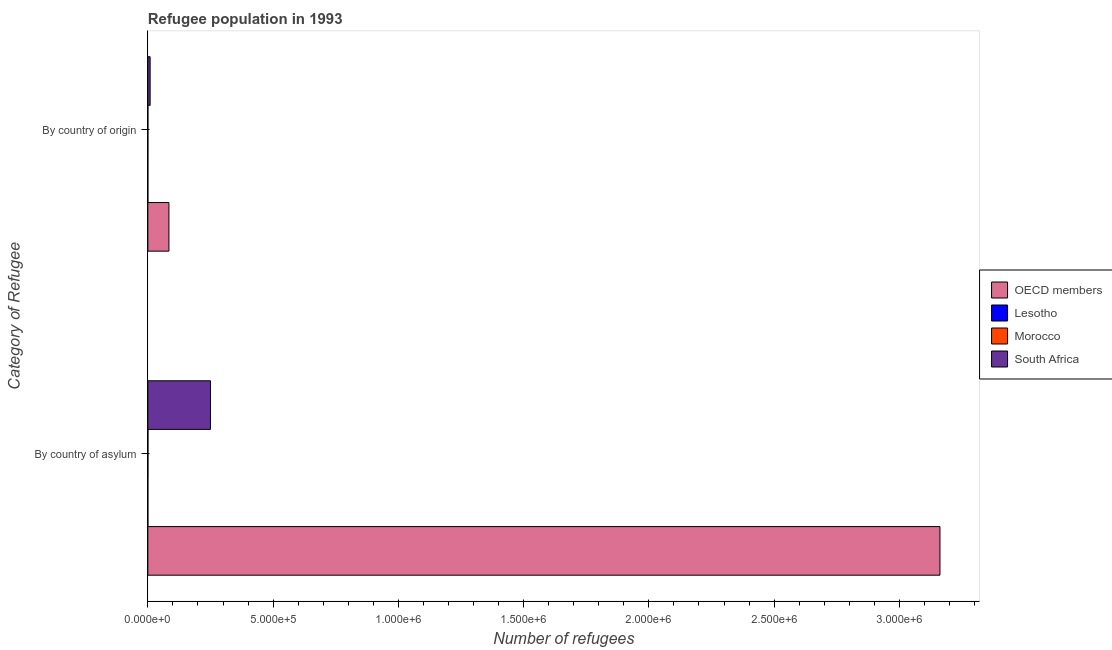How many different coloured bars are there?
Your answer should be compact. 4. Are the number of bars on each tick of the Y-axis equal?
Give a very brief answer. Yes. How many bars are there on the 1st tick from the bottom?
Give a very brief answer. 4. What is the label of the 2nd group of bars from the top?
Your answer should be very brief. By country of asylum. What is the number of refugees by country of asylum in OECD members?
Provide a succinct answer. 3.16e+06. Across all countries, what is the maximum number of refugees by country of origin?
Ensure brevity in your answer.  8.41e+04. Across all countries, what is the minimum number of refugees by country of origin?
Ensure brevity in your answer.  55. In which country was the number of refugees by country of asylum minimum?
Ensure brevity in your answer.  Lesotho. What is the total number of refugees by country of asylum in the graph?
Provide a short and direct response. 3.41e+06. What is the difference between the number of refugees by country of origin in Lesotho and that in OECD members?
Make the answer very short. -8.41e+04. What is the difference between the number of refugees by country of origin in Morocco and the number of refugees by country of asylum in Lesotho?
Make the answer very short. 45. What is the average number of refugees by country of asylum per country?
Offer a terse response. 8.53e+05. What is the difference between the number of refugees by country of origin and number of refugees by country of asylum in Lesotho?
Make the answer very short. -5. In how many countries, is the number of refugees by country of asylum greater than 1100000 ?
Provide a short and direct response. 1. What is the ratio of the number of refugees by country of asylum in Morocco to that in Lesotho?
Your answer should be very brief. 5.6. Is the number of refugees by country of asylum in Lesotho less than that in Morocco?
Ensure brevity in your answer.  Yes. What does the 2nd bar from the bottom in By country of asylum represents?
Your answer should be compact. Lesotho. How many countries are there in the graph?
Your answer should be compact. 4. Are the values on the major ticks of X-axis written in scientific E-notation?
Offer a very short reply. Yes. Does the graph contain grids?
Provide a short and direct response. No. How many legend labels are there?
Provide a short and direct response. 4. What is the title of the graph?
Your answer should be very brief. Refugee population in 1993. Does "Northern Mariana Islands" appear as one of the legend labels in the graph?
Make the answer very short. No. What is the label or title of the X-axis?
Keep it short and to the point. Number of refugees. What is the label or title of the Y-axis?
Provide a succinct answer. Category of Refugee. What is the Number of refugees of OECD members in By country of asylum?
Provide a short and direct response. 3.16e+06. What is the Number of refugees in Lesotho in By country of asylum?
Ensure brevity in your answer.  60. What is the Number of refugees in Morocco in By country of asylum?
Make the answer very short. 336. What is the Number of refugees in South Africa in By country of asylum?
Give a very brief answer. 2.50e+05. What is the Number of refugees in OECD members in By country of origin?
Your answer should be very brief. 8.41e+04. What is the Number of refugees of Lesotho in By country of origin?
Your answer should be compact. 55. What is the Number of refugees of Morocco in By country of origin?
Offer a terse response. 105. What is the Number of refugees of South Africa in By country of origin?
Make the answer very short. 9094. Across all Category of Refugee, what is the maximum Number of refugees of OECD members?
Make the answer very short. 3.16e+06. Across all Category of Refugee, what is the maximum Number of refugees in Morocco?
Your answer should be very brief. 336. Across all Category of Refugee, what is the maximum Number of refugees in South Africa?
Your answer should be compact. 2.50e+05. Across all Category of Refugee, what is the minimum Number of refugees in OECD members?
Provide a short and direct response. 8.41e+04. Across all Category of Refugee, what is the minimum Number of refugees of Lesotho?
Your answer should be compact. 55. Across all Category of Refugee, what is the minimum Number of refugees of Morocco?
Offer a very short reply. 105. Across all Category of Refugee, what is the minimum Number of refugees in South Africa?
Your answer should be very brief. 9094. What is the total Number of refugees in OECD members in the graph?
Your answer should be very brief. 3.25e+06. What is the total Number of refugees in Lesotho in the graph?
Give a very brief answer. 115. What is the total Number of refugees of Morocco in the graph?
Provide a short and direct response. 441. What is the total Number of refugees of South Africa in the graph?
Offer a very short reply. 2.59e+05. What is the difference between the Number of refugees in OECD members in By country of asylum and that in By country of origin?
Your answer should be compact. 3.08e+06. What is the difference between the Number of refugees in Morocco in By country of asylum and that in By country of origin?
Make the answer very short. 231. What is the difference between the Number of refugees of South Africa in By country of asylum and that in By country of origin?
Give a very brief answer. 2.41e+05. What is the difference between the Number of refugees of OECD members in By country of asylum and the Number of refugees of Lesotho in By country of origin?
Ensure brevity in your answer.  3.16e+06. What is the difference between the Number of refugees of OECD members in By country of asylum and the Number of refugees of Morocco in By country of origin?
Offer a terse response. 3.16e+06. What is the difference between the Number of refugees in OECD members in By country of asylum and the Number of refugees in South Africa in By country of origin?
Make the answer very short. 3.15e+06. What is the difference between the Number of refugees in Lesotho in By country of asylum and the Number of refugees in Morocco in By country of origin?
Provide a short and direct response. -45. What is the difference between the Number of refugees in Lesotho in By country of asylum and the Number of refugees in South Africa in By country of origin?
Ensure brevity in your answer.  -9034. What is the difference between the Number of refugees in Morocco in By country of asylum and the Number of refugees in South Africa in By country of origin?
Make the answer very short. -8758. What is the average Number of refugees in OECD members per Category of Refugee?
Your answer should be very brief. 1.62e+06. What is the average Number of refugees in Lesotho per Category of Refugee?
Offer a terse response. 57.5. What is the average Number of refugees of Morocco per Category of Refugee?
Your answer should be compact. 220.5. What is the average Number of refugees of South Africa per Category of Refugee?
Ensure brevity in your answer.  1.30e+05. What is the difference between the Number of refugees in OECD members and Number of refugees in Lesotho in By country of asylum?
Provide a succinct answer. 3.16e+06. What is the difference between the Number of refugees of OECD members and Number of refugees of Morocco in By country of asylum?
Your answer should be compact. 3.16e+06. What is the difference between the Number of refugees of OECD members and Number of refugees of South Africa in By country of asylum?
Keep it short and to the point. 2.91e+06. What is the difference between the Number of refugees in Lesotho and Number of refugees in Morocco in By country of asylum?
Your response must be concise. -276. What is the difference between the Number of refugees in Lesotho and Number of refugees in South Africa in By country of asylum?
Give a very brief answer. -2.50e+05. What is the difference between the Number of refugees in Morocco and Number of refugees in South Africa in By country of asylum?
Make the answer very short. -2.50e+05. What is the difference between the Number of refugees of OECD members and Number of refugees of Lesotho in By country of origin?
Make the answer very short. 8.41e+04. What is the difference between the Number of refugees of OECD members and Number of refugees of Morocco in By country of origin?
Offer a very short reply. 8.40e+04. What is the difference between the Number of refugees of OECD members and Number of refugees of South Africa in By country of origin?
Offer a very short reply. 7.50e+04. What is the difference between the Number of refugees in Lesotho and Number of refugees in South Africa in By country of origin?
Make the answer very short. -9039. What is the difference between the Number of refugees of Morocco and Number of refugees of South Africa in By country of origin?
Provide a short and direct response. -8989. What is the ratio of the Number of refugees in OECD members in By country of asylum to that in By country of origin?
Give a very brief answer. 37.58. What is the ratio of the Number of refugees of South Africa in By country of asylum to that in By country of origin?
Make the answer very short. 27.49. What is the difference between the highest and the second highest Number of refugees of OECD members?
Provide a succinct answer. 3.08e+06. What is the difference between the highest and the second highest Number of refugees in Lesotho?
Your response must be concise. 5. What is the difference between the highest and the second highest Number of refugees in Morocco?
Your response must be concise. 231. What is the difference between the highest and the second highest Number of refugees of South Africa?
Offer a very short reply. 2.41e+05. What is the difference between the highest and the lowest Number of refugees in OECD members?
Your response must be concise. 3.08e+06. What is the difference between the highest and the lowest Number of refugees in Lesotho?
Ensure brevity in your answer.  5. What is the difference between the highest and the lowest Number of refugees of Morocco?
Your answer should be very brief. 231. What is the difference between the highest and the lowest Number of refugees of South Africa?
Your answer should be compact. 2.41e+05. 